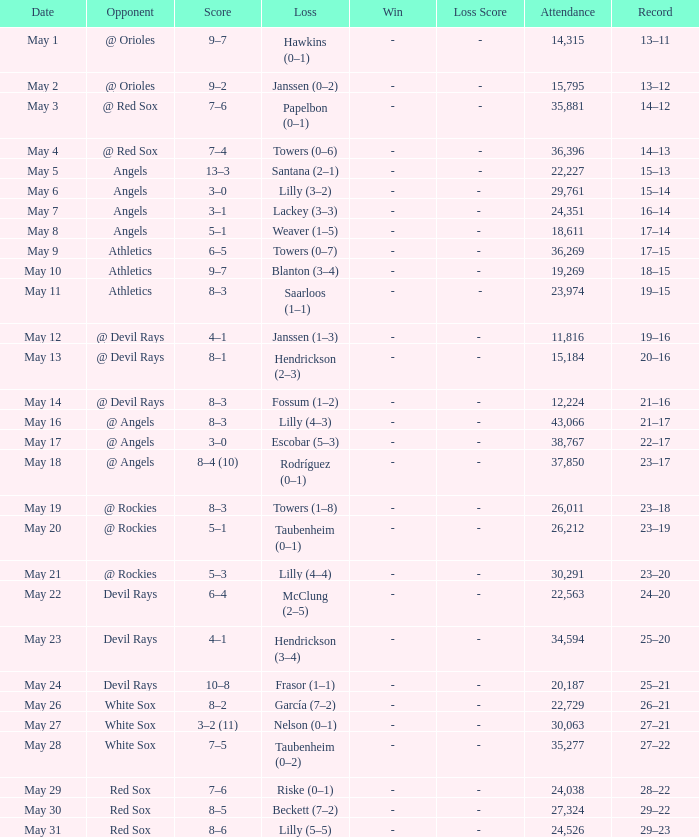When the team had their record of 16–14, what was the total attendance? 1.0. 